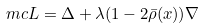Convert formula to latex. <formula><loc_0><loc_0><loc_500><loc_500>\ m c L & = \Delta + \lambda ( 1 - 2 \bar { \rho } ( x ) ) \nabla</formula> 